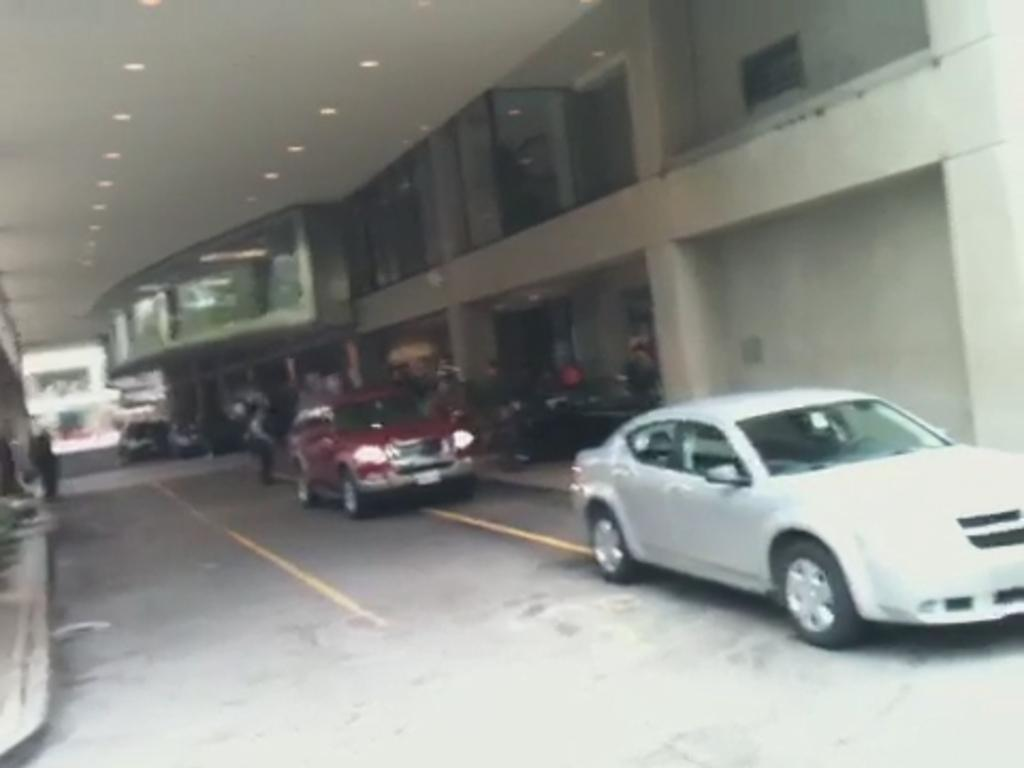What type of structure is visible in the image? There is a building in the image. What can be seen on the road in the image? There are cars on the road in the image. Where are the lights located in the image? The lights are on the ceiling in the top left of the image. Are there any dinosaurs visible in the image? No, there are no dinosaurs present in the image. Can you see a kitten playing with the lights in the image? No, there is no kitten present in the image. 